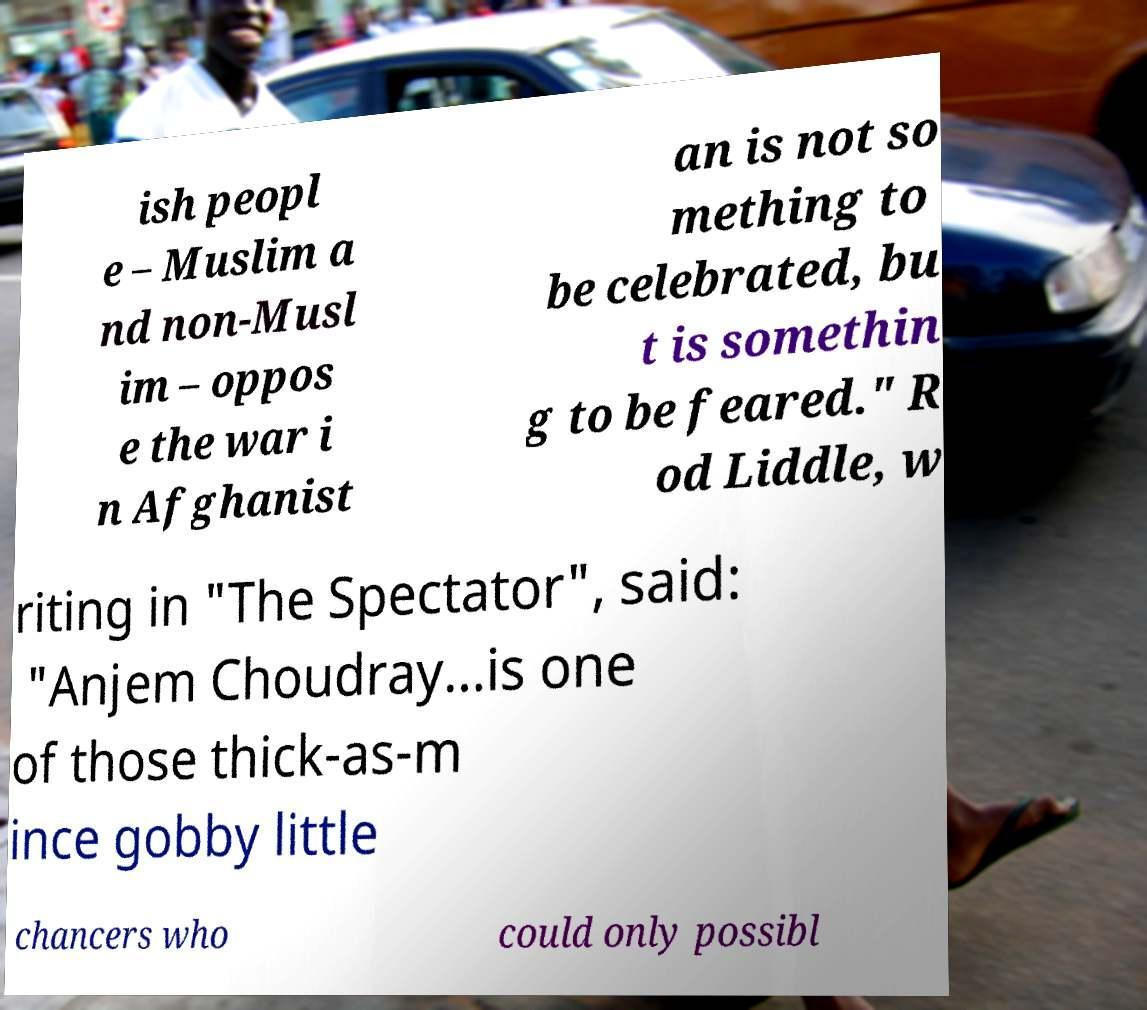Could you assist in decoding the text presented in this image and type it out clearly? ish peopl e – Muslim a nd non-Musl im – oppos e the war i n Afghanist an is not so mething to be celebrated, bu t is somethin g to be feared." R od Liddle, w riting in "The Spectator", said: "Anjem Choudray...is one of those thick-as-m ince gobby little chancers who could only possibl 